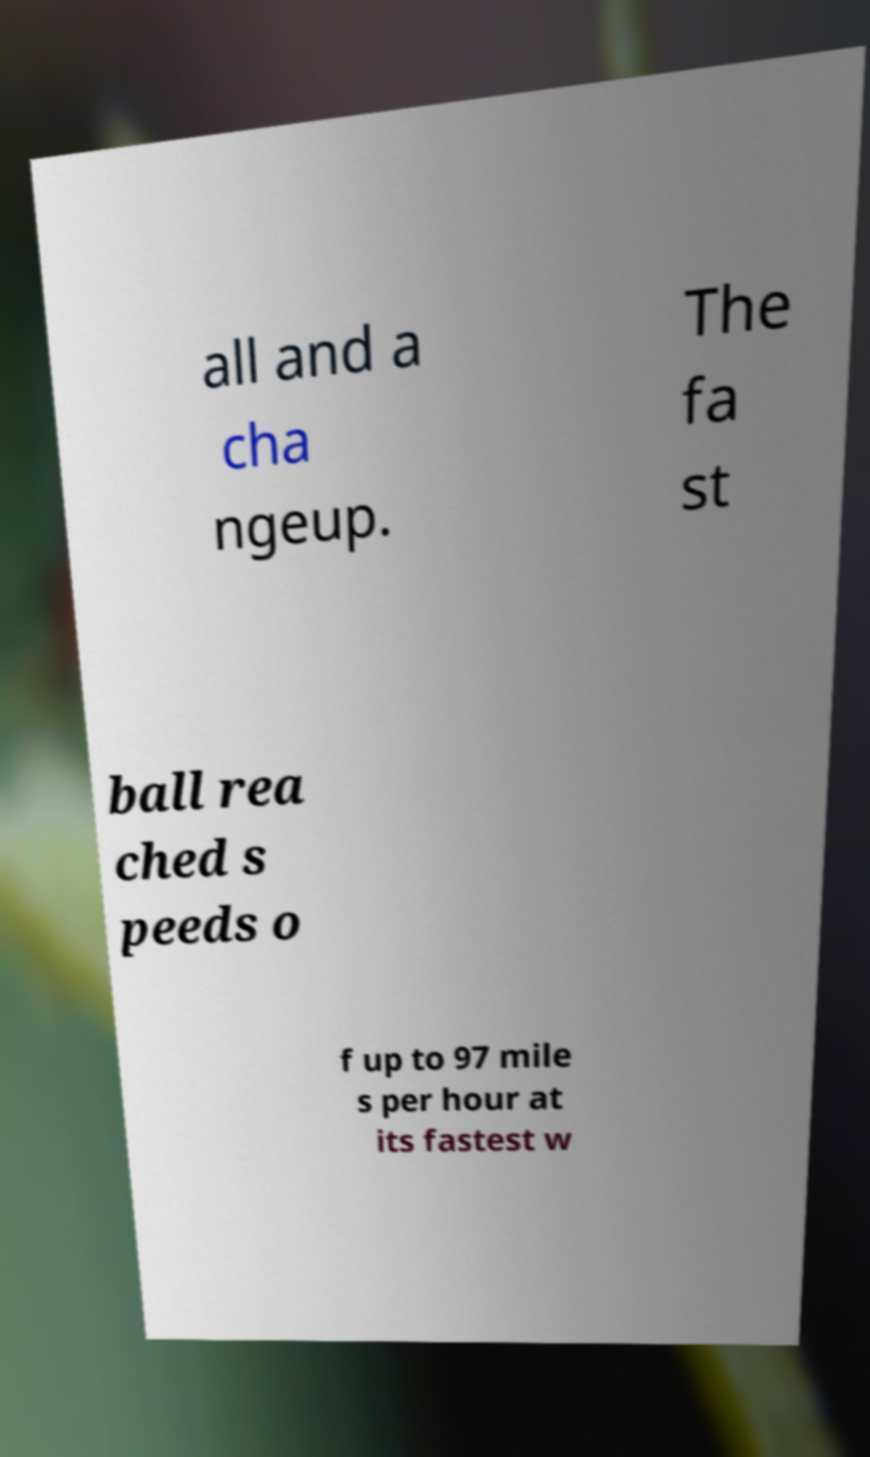Could you assist in decoding the text presented in this image and type it out clearly? all and a cha ngeup. The fa st ball rea ched s peeds o f up to 97 mile s per hour at its fastest w 